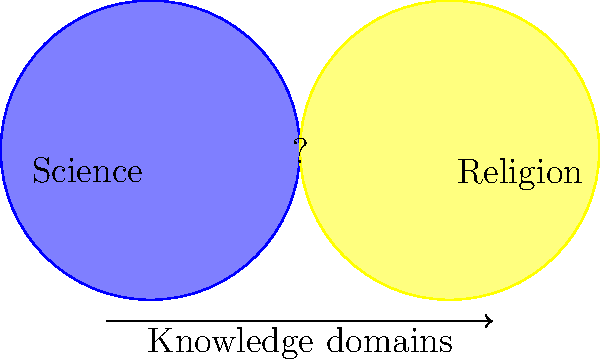In the diagram, two circles represent the domains of science and religion. What does the overlapping region (marked with a "?") most likely represent in the context of the philosophical view that science and religion operate in separate domains of knowledge? To answer this question, let's consider the philosophical perspective step by step:

1. The given persona argues that science and religion operate in separate domains of knowledge.
2. In the diagram, we see two circles: one representing science and one representing religion.
3. These circles are overlapping, creating three distinct regions:
   a. A region exclusive to science
   b. A region exclusive to religion
   c. An overlapping region (marked with "?")
4. Given the philosophical stance that science and religion are separate domains, the overlapping region should not represent a significant area of shared knowledge or methodology.
5. Instead, this region likely represents areas where both science and religion might comment on the same topics but from fundamentally different perspectives or approaches.
6. This area could be seen as a potential source of conflict or misunderstanding when the boundaries between scientific and religious discourse are not clearly delineated.
7. In the context of the given philosophical view, this region might be best described as an area of "apparent overlap" or "perceived intersection" rather than a true integration of scientific and religious knowledge.

Therefore, the overlapping region most likely represents an area of perceived intersection or potential conflict, rather than a genuine integration of scientific and religious knowledge.
Answer: Area of perceived intersection or potential conflict 